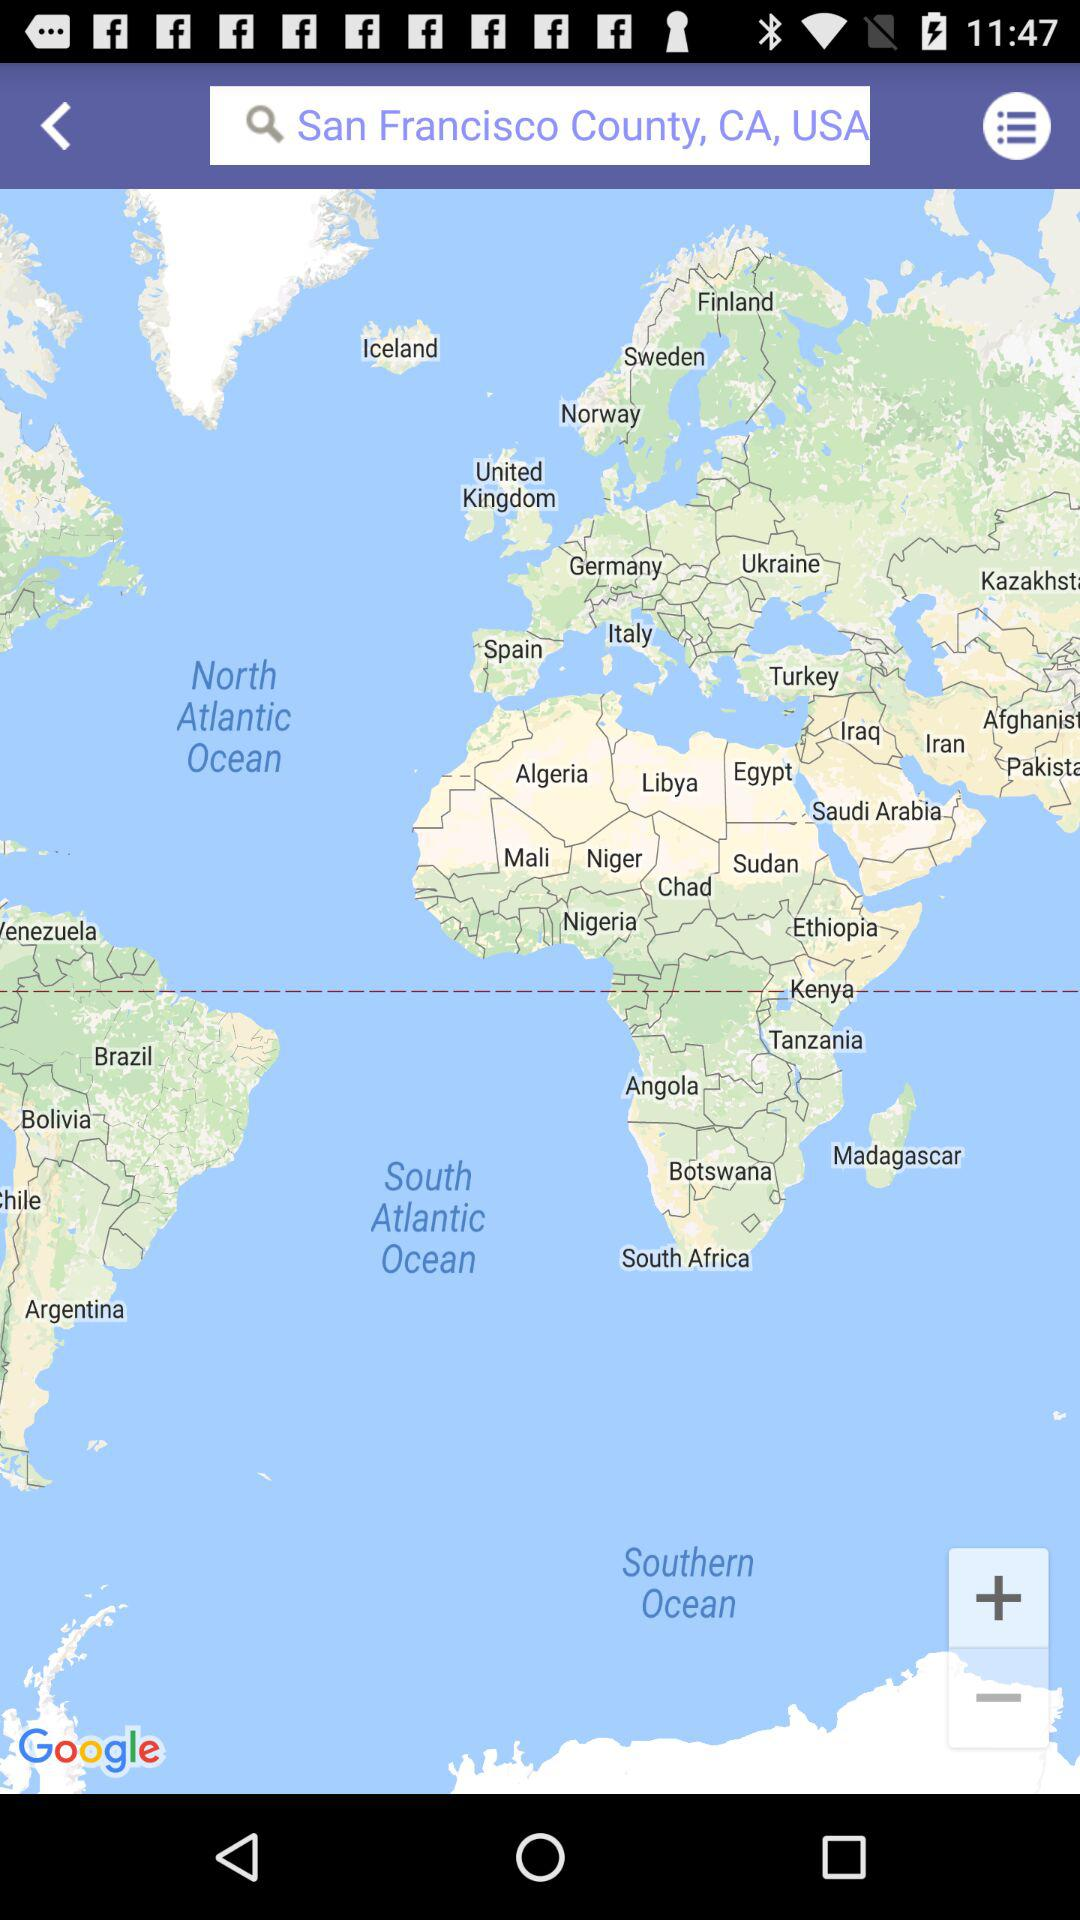How far away is San Francisco County?
When the provided information is insufficient, respond with <no answer>. <no answer> 